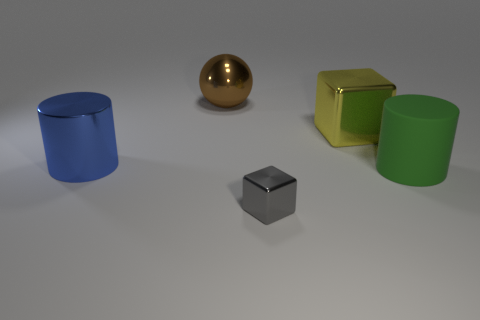Is the size of the cube in front of the large blue object the same as the block behind the gray shiny block?
Provide a short and direct response. No. There is a cylinder that is to the left of the cylinder on the right side of the brown metallic ball; how big is it?
Make the answer very short. Large. What is the material of the large object that is on the right side of the blue thing and on the left side of the gray cube?
Your answer should be very brief. Metal. The large cube has what color?
Your response must be concise. Yellow. Are there any other things that have the same material as the green thing?
Ensure brevity in your answer.  No. The shiny thing that is in front of the large green matte object has what shape?
Offer a very short reply. Cube. There is a large rubber object that is on the right side of the thing on the left side of the large metallic sphere; is there a block that is behind it?
Your answer should be compact. Yes. Is there anything else that has the same shape as the brown metallic thing?
Your response must be concise. No. Are there any big yellow shiny things?
Give a very brief answer. Yes. Are the large cylinder that is right of the blue cylinder and the cylinder that is to the left of the big shiny ball made of the same material?
Provide a short and direct response. No. 